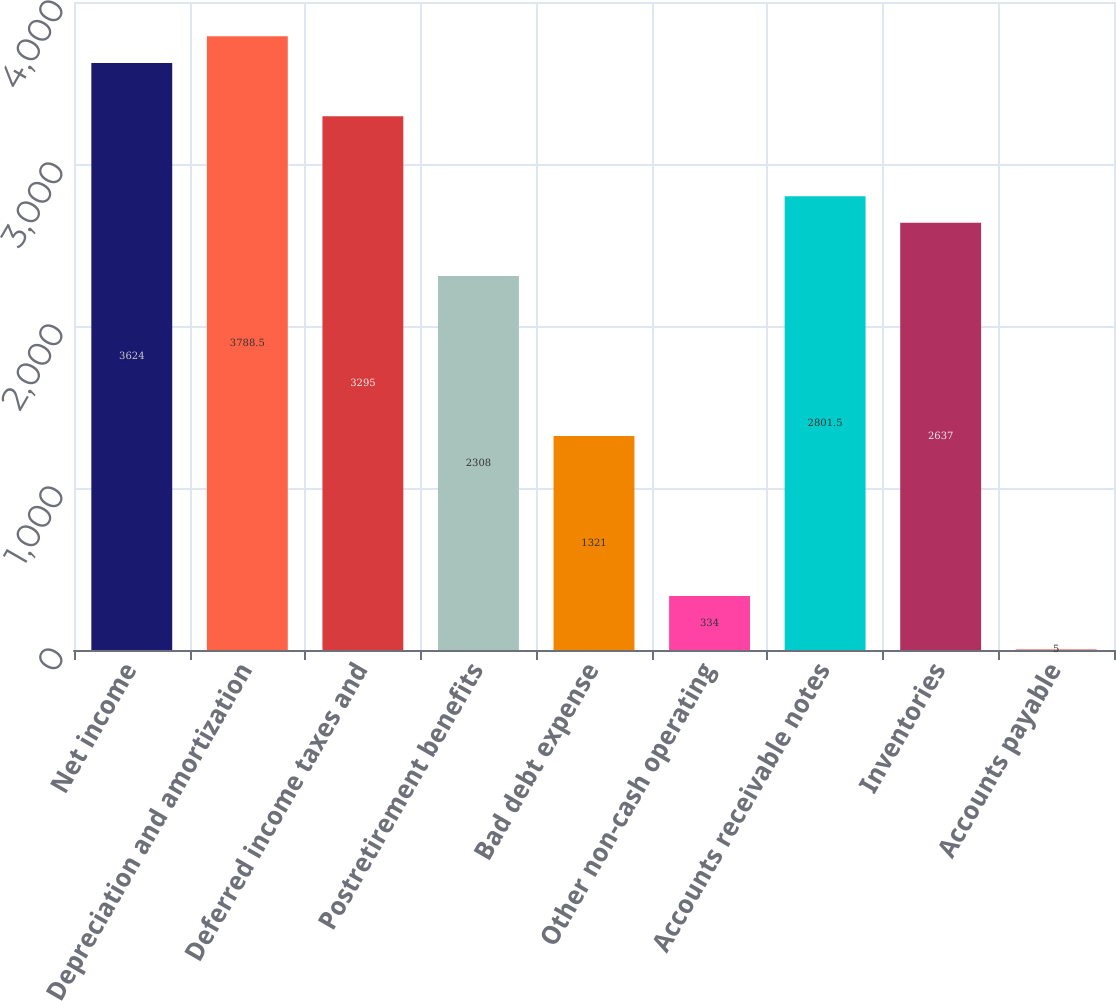<chart> <loc_0><loc_0><loc_500><loc_500><bar_chart><fcel>Net income<fcel>Depreciation and amortization<fcel>Deferred income taxes and<fcel>Postretirement benefits<fcel>Bad debt expense<fcel>Other non-cash operating<fcel>Accounts receivable notes<fcel>Inventories<fcel>Accounts payable<nl><fcel>3624<fcel>3788.5<fcel>3295<fcel>2308<fcel>1321<fcel>334<fcel>2801.5<fcel>2637<fcel>5<nl></chart> 